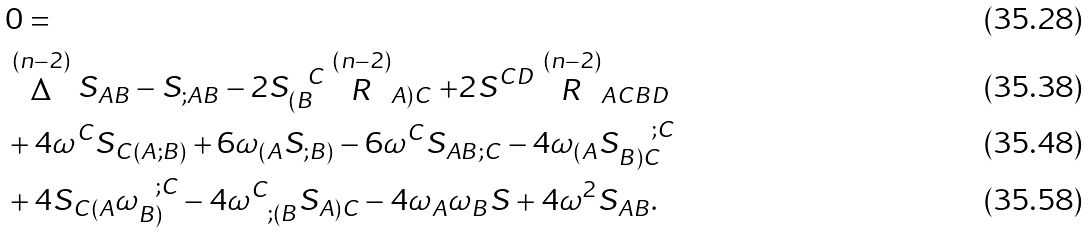<formula> <loc_0><loc_0><loc_500><loc_500>& 0 = \\ & \stackrel { ( n - 2 ) } { \Delta } S _ { A B } - S _ { ; A B } - 2 S _ { ( B } ^ { \ \ C } \stackrel { ( n - 2 ) } { R } _ { A ) C } + 2 S ^ { C D } \stackrel { ( n - 2 ) } { R } _ { A C B D } \\ & + 4 \omega ^ { C } S _ { C ( A ; B ) } + 6 \omega _ { ( A } S _ { ; B ) } - 6 \omega ^ { C } S _ { A B ; C } - 4 \omega _ { ( A } S _ { B ) C } ^ { \quad ; C } \\ & + 4 S _ { C ( A } \omega _ { B ) } ^ { \ \ ; C } - 4 \omega ^ { C } _ { \ \ ; ( B } S _ { A ) C } - 4 \omega _ { A } \omega _ { B } S + 4 \omega ^ { 2 } S _ { A B } .</formula> 